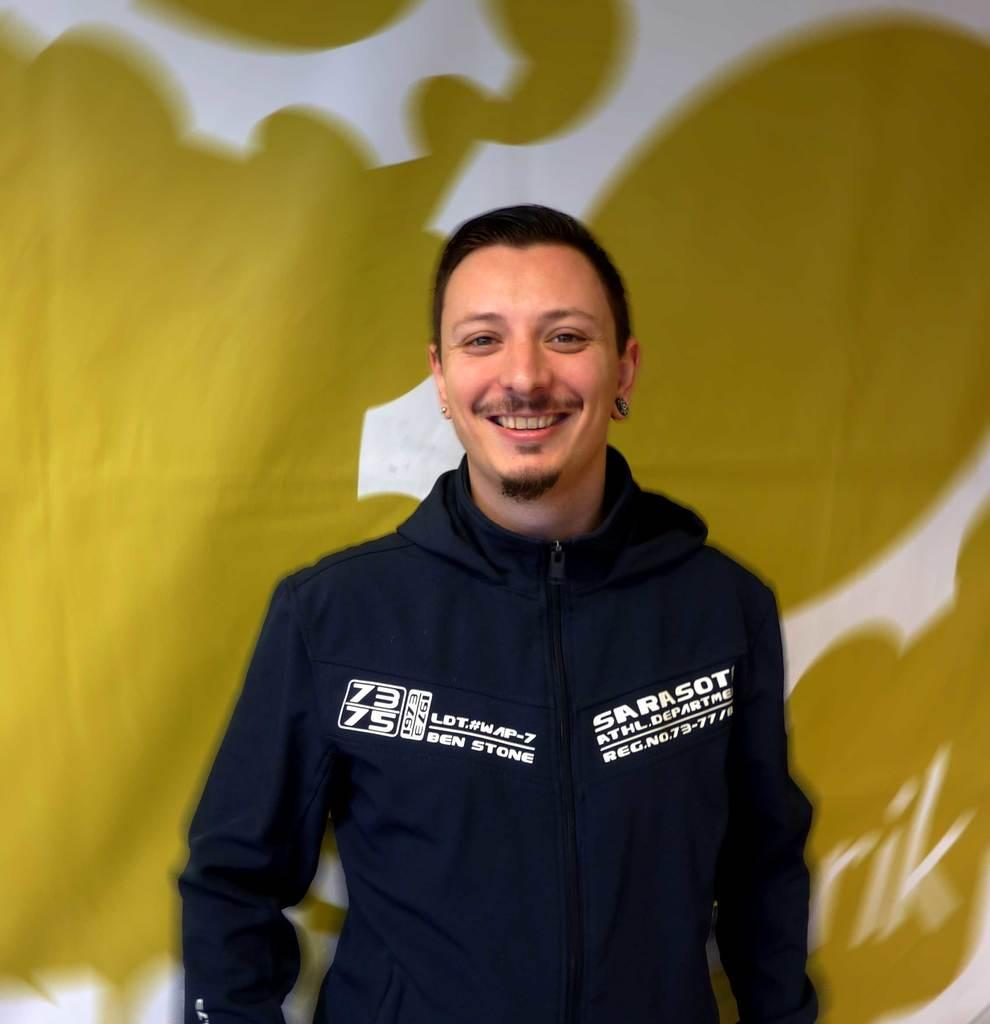<image>
Offer a succinct explanation of the picture presented. A man wearing a navy blue jacket with Ben Stone embroidered one side. 